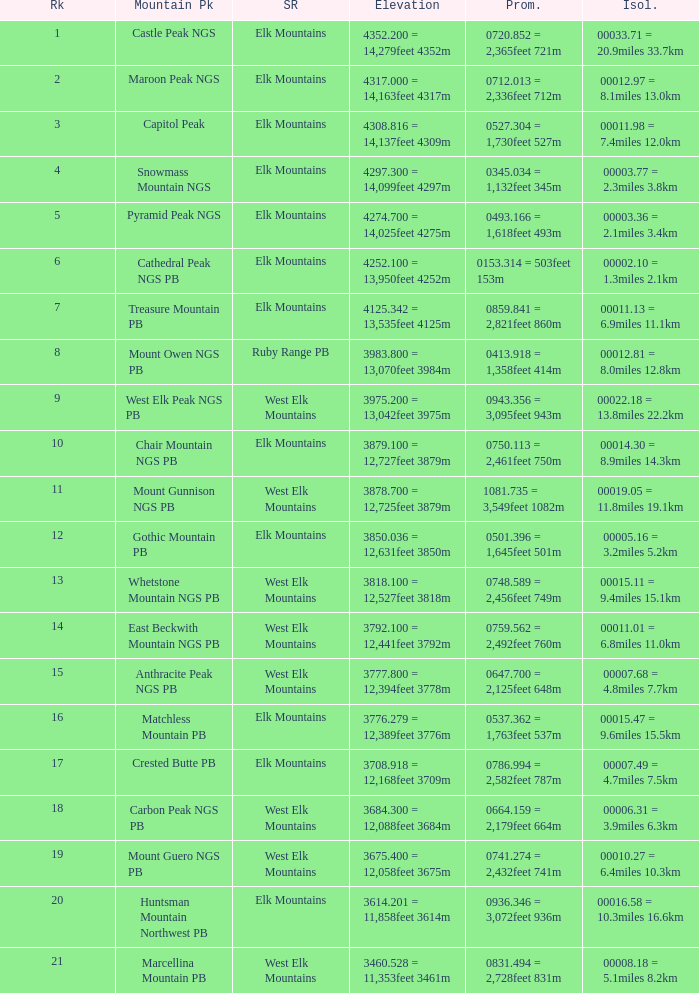Name the Prominence of the Mountain Peak of matchless mountain pb? 0537.362 = 1,763feet 537m. 